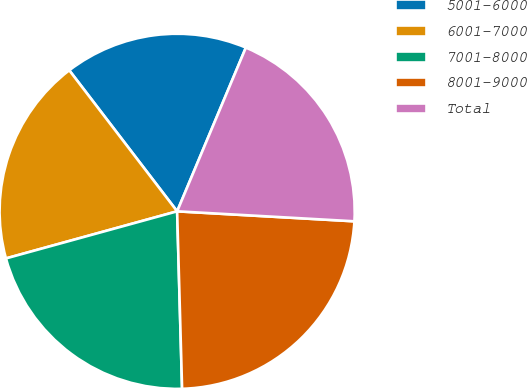Convert chart. <chart><loc_0><loc_0><loc_500><loc_500><pie_chart><fcel>5001-6000<fcel>6001-7000<fcel>7001-8000<fcel>8001-9000<fcel>Total<nl><fcel>16.72%<fcel>18.88%<fcel>21.17%<fcel>23.66%<fcel>19.57%<nl></chart> 